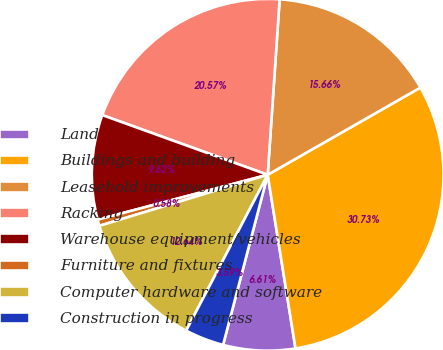Convert chart. <chart><loc_0><loc_0><loc_500><loc_500><pie_chart><fcel>Land<fcel>Buildings and building<fcel>Leasehold improvements<fcel>Racking<fcel>Warehouse equipment/vehicles<fcel>Furniture and fixtures<fcel>Computer hardware and software<fcel>Construction in progress<nl><fcel>6.61%<fcel>30.73%<fcel>15.66%<fcel>20.57%<fcel>9.62%<fcel>0.58%<fcel>12.64%<fcel>3.59%<nl></chart> 